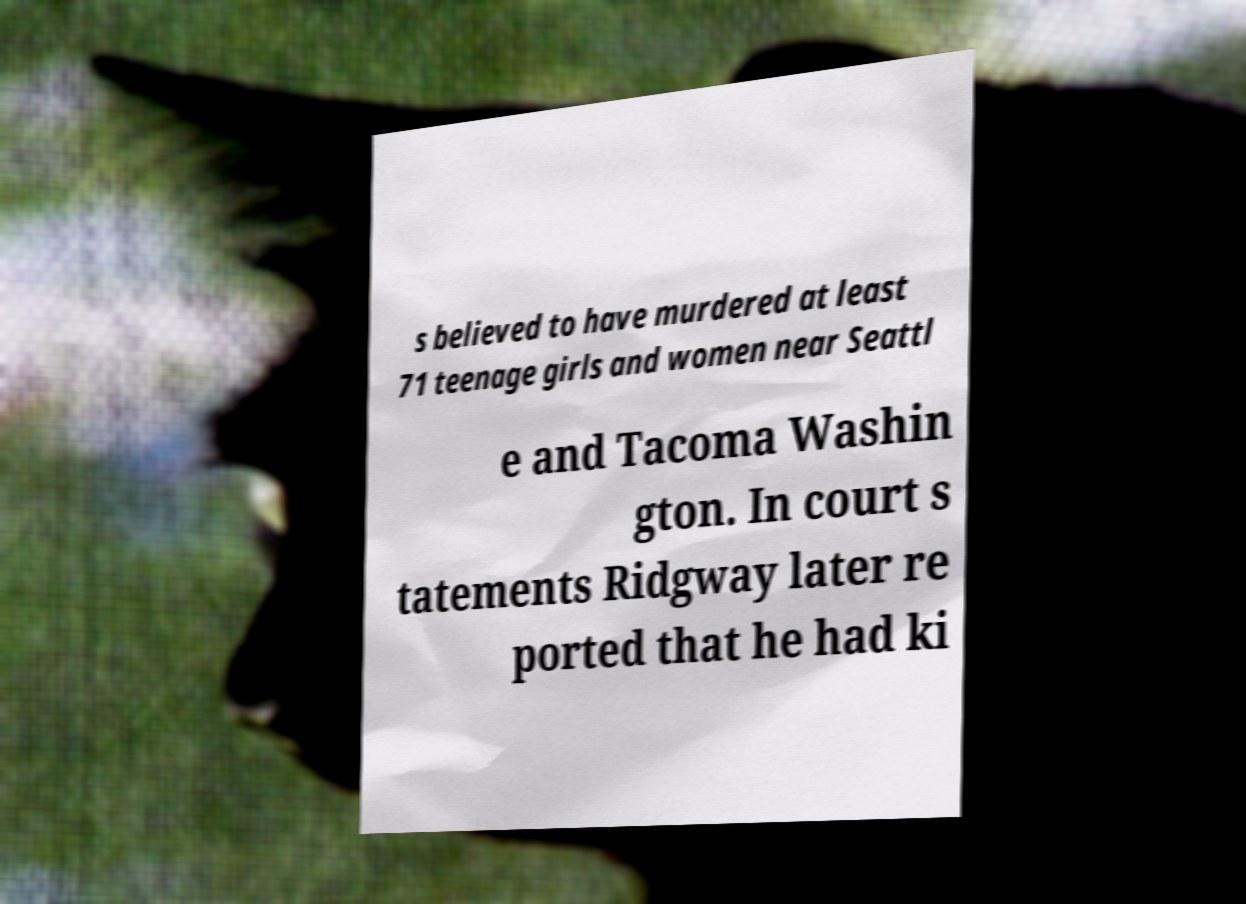Could you extract and type out the text from this image? s believed to have murdered at least 71 teenage girls and women near Seattl e and Tacoma Washin gton. In court s tatements Ridgway later re ported that he had ki 